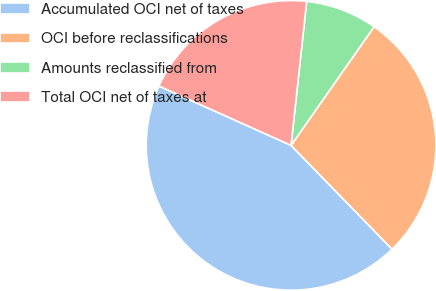Convert chart to OTSL. <chart><loc_0><loc_0><loc_500><loc_500><pie_chart><fcel>Accumulated OCI net of taxes<fcel>OCI before reclassifications<fcel>Amounts reclassified from<fcel>Total OCI net of taxes at<nl><fcel>44.0%<fcel>28.0%<fcel>8.0%<fcel>20.0%<nl></chart> 